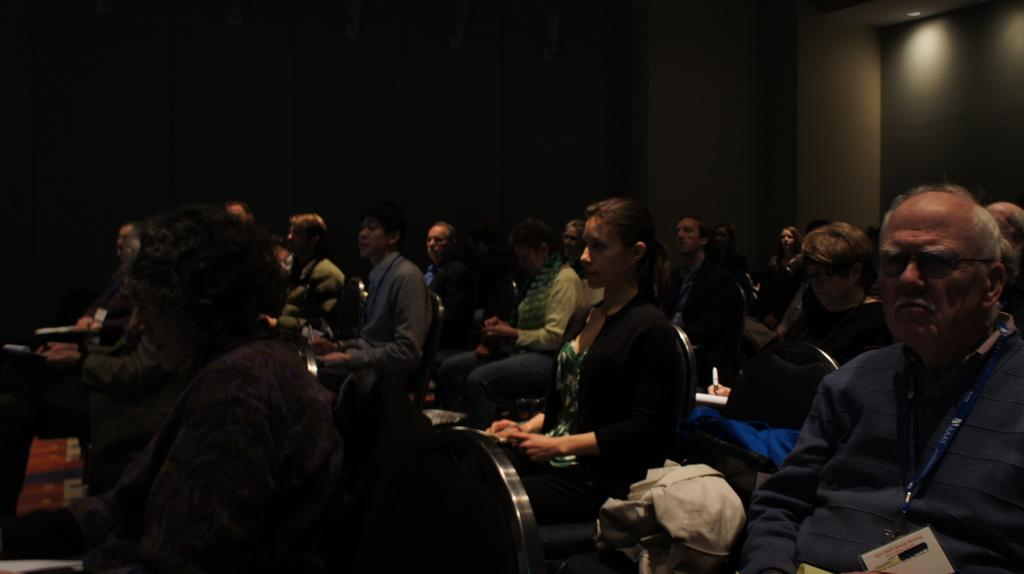What are the people in the image doing? The people in the image are sitting on chairs. What can be observed about the lighting in the image? The background of the image is dark. How many oranges are being played on the record in the image? There are no oranges or records present in the image. What type of authority figure is depicted in the image? There is no authority figure depicted in the image; it only shows people sitting on chairs. 